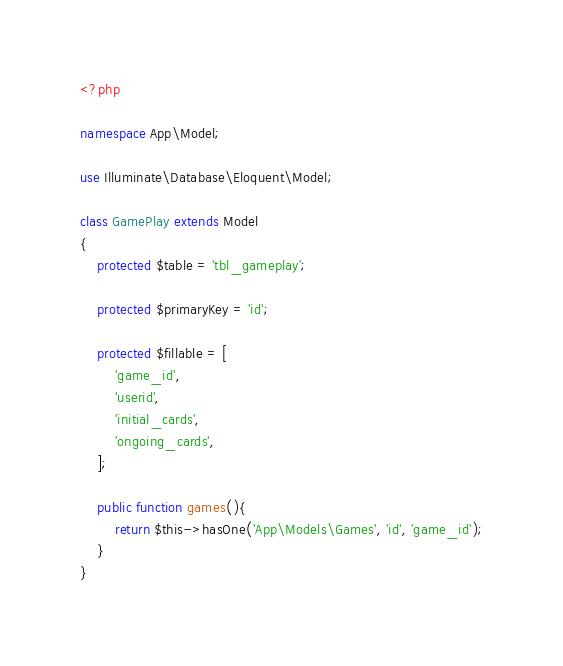Convert code to text. <code><loc_0><loc_0><loc_500><loc_500><_PHP_><?php

namespace App\Model;

use Illuminate\Database\Eloquent\Model;

class GamePlay extends Model
{
    protected $table = 'tbl_gameplay';
	
    protected $primaryKey = 'id';

	protected $fillable = [
        'game_id',
        'userid',
        'initial_cards',
        'ongoing_cards',
    ];

    public function games(){
        return $this->hasOne('App\Models\Games', 'id', 'game_id');
    }
}
</code> 